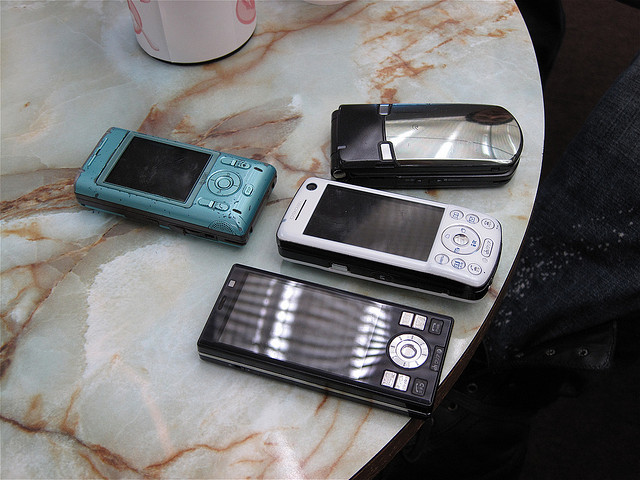<image>How old do you think these phones are? It is ambiguous to say exactly how old these phones are, but estimates range from 2 to 15 years. How old do you think these phones are? I don't know how old these phones are. It could be any of the given options. 